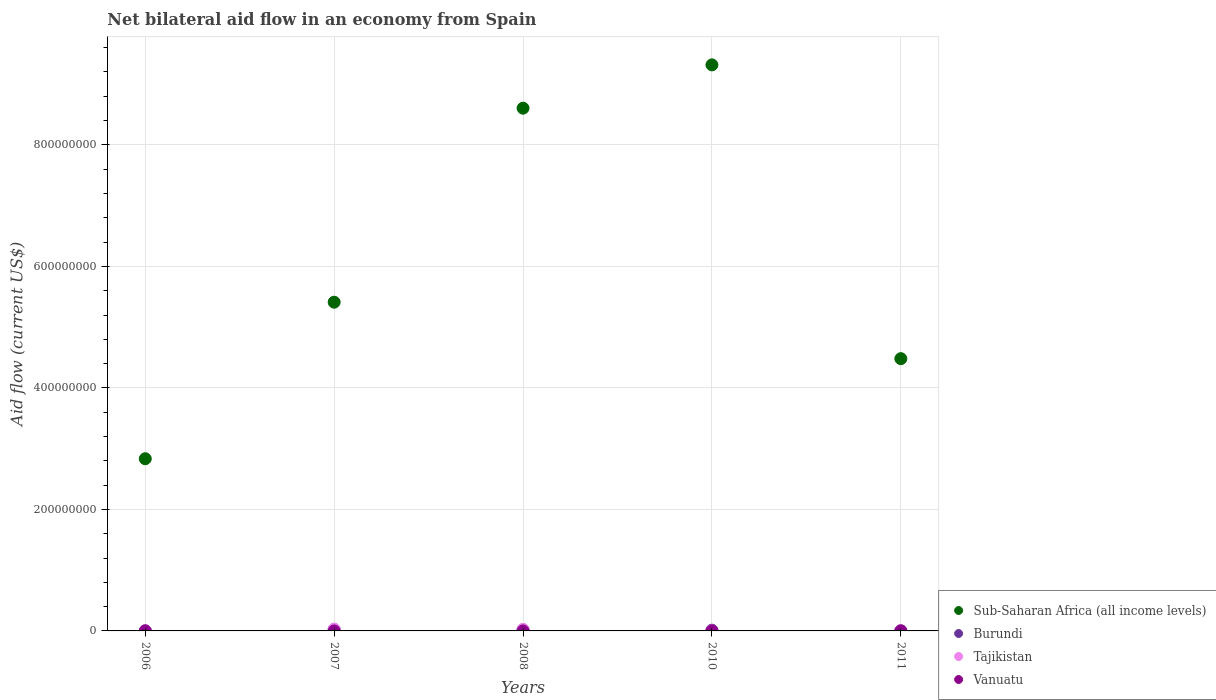How many different coloured dotlines are there?
Your answer should be very brief. 4. What is the net bilateral aid flow in Burundi in 2008?
Give a very brief answer. 1.88e+06. Across all years, what is the maximum net bilateral aid flow in Tajikistan?
Offer a very short reply. 3.04e+06. In which year was the net bilateral aid flow in Vanuatu maximum?
Offer a very short reply. 2011. In which year was the net bilateral aid flow in Vanuatu minimum?
Your response must be concise. 2006. What is the total net bilateral aid flow in Tajikistan in the graph?
Your answer should be compact. 5.67e+06. What is the difference between the net bilateral aid flow in Burundi in 2006 and the net bilateral aid flow in Vanuatu in 2010?
Your answer should be compact. 1.90e+05. What is the average net bilateral aid flow in Burundi per year?
Your response must be concise. 1.17e+06. In the year 2011, what is the difference between the net bilateral aid flow in Vanuatu and net bilateral aid flow in Tajikistan?
Provide a succinct answer. -3.00e+04. In how many years, is the net bilateral aid flow in Burundi greater than 320000000 US$?
Offer a very short reply. 0. What is the ratio of the net bilateral aid flow in Vanuatu in 2007 to that in 2010?
Your response must be concise. 0.33. Is the net bilateral aid flow in Tajikistan in 2007 less than that in 2008?
Make the answer very short. No. Is the difference between the net bilateral aid flow in Vanuatu in 2007 and 2010 greater than the difference between the net bilateral aid flow in Tajikistan in 2007 and 2010?
Offer a very short reply. No. What is the difference between the highest and the lowest net bilateral aid flow in Sub-Saharan Africa (all income levels)?
Keep it short and to the point. 6.48e+08. In how many years, is the net bilateral aid flow in Sub-Saharan Africa (all income levels) greater than the average net bilateral aid flow in Sub-Saharan Africa (all income levels) taken over all years?
Your response must be concise. 2. Is the sum of the net bilateral aid flow in Tajikistan in 2007 and 2011 greater than the maximum net bilateral aid flow in Sub-Saharan Africa (all income levels) across all years?
Keep it short and to the point. No. Is it the case that in every year, the sum of the net bilateral aid flow in Vanuatu and net bilateral aid flow in Tajikistan  is greater than the sum of net bilateral aid flow in Sub-Saharan Africa (all income levels) and net bilateral aid flow in Burundi?
Provide a succinct answer. No. Is it the case that in every year, the sum of the net bilateral aid flow in Vanuatu and net bilateral aid flow in Burundi  is greater than the net bilateral aid flow in Tajikistan?
Provide a succinct answer. No. How many dotlines are there?
Provide a succinct answer. 4. What is the difference between two consecutive major ticks on the Y-axis?
Offer a very short reply. 2.00e+08. Does the graph contain any zero values?
Keep it short and to the point. No. Does the graph contain grids?
Provide a short and direct response. Yes. How many legend labels are there?
Your answer should be very brief. 4. How are the legend labels stacked?
Ensure brevity in your answer.  Vertical. What is the title of the graph?
Your answer should be very brief. Net bilateral aid flow in an economy from Spain. Does "Isle of Man" appear as one of the legend labels in the graph?
Offer a very short reply. No. What is the label or title of the X-axis?
Your response must be concise. Years. What is the Aid flow (current US$) of Sub-Saharan Africa (all income levels) in 2006?
Your answer should be very brief. 2.83e+08. What is the Aid flow (current US$) in Vanuatu in 2006?
Your response must be concise. 10000. What is the Aid flow (current US$) of Sub-Saharan Africa (all income levels) in 2007?
Your answer should be compact. 5.41e+08. What is the Aid flow (current US$) of Burundi in 2007?
Offer a very short reply. 2.29e+06. What is the Aid flow (current US$) of Tajikistan in 2007?
Offer a very short reply. 3.04e+06. What is the Aid flow (current US$) of Vanuatu in 2007?
Your answer should be compact. 10000. What is the Aid flow (current US$) in Sub-Saharan Africa (all income levels) in 2008?
Provide a succinct answer. 8.60e+08. What is the Aid flow (current US$) of Burundi in 2008?
Offer a very short reply. 1.88e+06. What is the Aid flow (current US$) of Tajikistan in 2008?
Give a very brief answer. 2.49e+06. What is the Aid flow (current US$) in Sub-Saharan Africa (all income levels) in 2010?
Give a very brief answer. 9.32e+08. What is the Aid flow (current US$) in Burundi in 2010?
Your answer should be compact. 1.24e+06. What is the Aid flow (current US$) in Vanuatu in 2010?
Give a very brief answer. 3.00e+04. What is the Aid flow (current US$) of Sub-Saharan Africa (all income levels) in 2011?
Offer a terse response. 4.48e+08. What is the Aid flow (current US$) in Burundi in 2011?
Ensure brevity in your answer.  2.00e+05. What is the Aid flow (current US$) of Tajikistan in 2011?
Offer a terse response. 7.00e+04. What is the Aid flow (current US$) of Vanuatu in 2011?
Offer a terse response. 4.00e+04. Across all years, what is the maximum Aid flow (current US$) in Sub-Saharan Africa (all income levels)?
Your answer should be very brief. 9.32e+08. Across all years, what is the maximum Aid flow (current US$) in Burundi?
Your response must be concise. 2.29e+06. Across all years, what is the maximum Aid flow (current US$) in Tajikistan?
Give a very brief answer. 3.04e+06. Across all years, what is the maximum Aid flow (current US$) in Vanuatu?
Offer a very short reply. 4.00e+04. Across all years, what is the minimum Aid flow (current US$) of Sub-Saharan Africa (all income levels)?
Your answer should be compact. 2.83e+08. Across all years, what is the minimum Aid flow (current US$) in Tajikistan?
Your answer should be very brief. 2.00e+04. Across all years, what is the minimum Aid flow (current US$) of Vanuatu?
Keep it short and to the point. 10000. What is the total Aid flow (current US$) in Sub-Saharan Africa (all income levels) in the graph?
Your answer should be compact. 3.06e+09. What is the total Aid flow (current US$) in Burundi in the graph?
Keep it short and to the point. 5.83e+06. What is the total Aid flow (current US$) in Tajikistan in the graph?
Keep it short and to the point. 5.67e+06. What is the difference between the Aid flow (current US$) in Sub-Saharan Africa (all income levels) in 2006 and that in 2007?
Provide a short and direct response. -2.58e+08. What is the difference between the Aid flow (current US$) in Burundi in 2006 and that in 2007?
Provide a short and direct response. -2.07e+06. What is the difference between the Aid flow (current US$) of Tajikistan in 2006 and that in 2007?
Offer a terse response. -2.99e+06. What is the difference between the Aid flow (current US$) in Sub-Saharan Africa (all income levels) in 2006 and that in 2008?
Your answer should be compact. -5.77e+08. What is the difference between the Aid flow (current US$) of Burundi in 2006 and that in 2008?
Provide a succinct answer. -1.66e+06. What is the difference between the Aid flow (current US$) of Tajikistan in 2006 and that in 2008?
Offer a terse response. -2.44e+06. What is the difference between the Aid flow (current US$) in Vanuatu in 2006 and that in 2008?
Your answer should be very brief. -2.00e+04. What is the difference between the Aid flow (current US$) of Sub-Saharan Africa (all income levels) in 2006 and that in 2010?
Offer a very short reply. -6.48e+08. What is the difference between the Aid flow (current US$) in Burundi in 2006 and that in 2010?
Offer a very short reply. -1.02e+06. What is the difference between the Aid flow (current US$) of Vanuatu in 2006 and that in 2010?
Offer a terse response. -2.00e+04. What is the difference between the Aid flow (current US$) in Sub-Saharan Africa (all income levels) in 2006 and that in 2011?
Your answer should be compact. -1.65e+08. What is the difference between the Aid flow (current US$) of Burundi in 2006 and that in 2011?
Your answer should be very brief. 2.00e+04. What is the difference between the Aid flow (current US$) in Vanuatu in 2006 and that in 2011?
Give a very brief answer. -3.00e+04. What is the difference between the Aid flow (current US$) in Sub-Saharan Africa (all income levels) in 2007 and that in 2008?
Provide a short and direct response. -3.19e+08. What is the difference between the Aid flow (current US$) in Sub-Saharan Africa (all income levels) in 2007 and that in 2010?
Provide a short and direct response. -3.91e+08. What is the difference between the Aid flow (current US$) of Burundi in 2007 and that in 2010?
Keep it short and to the point. 1.05e+06. What is the difference between the Aid flow (current US$) of Tajikistan in 2007 and that in 2010?
Provide a succinct answer. 3.02e+06. What is the difference between the Aid flow (current US$) of Vanuatu in 2007 and that in 2010?
Ensure brevity in your answer.  -2.00e+04. What is the difference between the Aid flow (current US$) of Sub-Saharan Africa (all income levels) in 2007 and that in 2011?
Provide a short and direct response. 9.29e+07. What is the difference between the Aid flow (current US$) of Burundi in 2007 and that in 2011?
Your answer should be very brief. 2.09e+06. What is the difference between the Aid flow (current US$) of Tajikistan in 2007 and that in 2011?
Provide a succinct answer. 2.97e+06. What is the difference between the Aid flow (current US$) in Sub-Saharan Africa (all income levels) in 2008 and that in 2010?
Make the answer very short. -7.13e+07. What is the difference between the Aid flow (current US$) in Burundi in 2008 and that in 2010?
Your answer should be very brief. 6.40e+05. What is the difference between the Aid flow (current US$) in Tajikistan in 2008 and that in 2010?
Make the answer very short. 2.47e+06. What is the difference between the Aid flow (current US$) in Sub-Saharan Africa (all income levels) in 2008 and that in 2011?
Provide a short and direct response. 4.12e+08. What is the difference between the Aid flow (current US$) in Burundi in 2008 and that in 2011?
Make the answer very short. 1.68e+06. What is the difference between the Aid flow (current US$) in Tajikistan in 2008 and that in 2011?
Your answer should be compact. 2.42e+06. What is the difference between the Aid flow (current US$) in Vanuatu in 2008 and that in 2011?
Make the answer very short. -10000. What is the difference between the Aid flow (current US$) of Sub-Saharan Africa (all income levels) in 2010 and that in 2011?
Your answer should be very brief. 4.84e+08. What is the difference between the Aid flow (current US$) of Burundi in 2010 and that in 2011?
Your answer should be very brief. 1.04e+06. What is the difference between the Aid flow (current US$) in Tajikistan in 2010 and that in 2011?
Make the answer very short. -5.00e+04. What is the difference between the Aid flow (current US$) in Sub-Saharan Africa (all income levels) in 2006 and the Aid flow (current US$) in Burundi in 2007?
Keep it short and to the point. 2.81e+08. What is the difference between the Aid flow (current US$) in Sub-Saharan Africa (all income levels) in 2006 and the Aid flow (current US$) in Tajikistan in 2007?
Keep it short and to the point. 2.80e+08. What is the difference between the Aid flow (current US$) of Sub-Saharan Africa (all income levels) in 2006 and the Aid flow (current US$) of Vanuatu in 2007?
Your answer should be very brief. 2.83e+08. What is the difference between the Aid flow (current US$) of Burundi in 2006 and the Aid flow (current US$) of Tajikistan in 2007?
Provide a short and direct response. -2.82e+06. What is the difference between the Aid flow (current US$) of Tajikistan in 2006 and the Aid flow (current US$) of Vanuatu in 2007?
Provide a succinct answer. 4.00e+04. What is the difference between the Aid flow (current US$) of Sub-Saharan Africa (all income levels) in 2006 and the Aid flow (current US$) of Burundi in 2008?
Make the answer very short. 2.82e+08. What is the difference between the Aid flow (current US$) of Sub-Saharan Africa (all income levels) in 2006 and the Aid flow (current US$) of Tajikistan in 2008?
Keep it short and to the point. 2.81e+08. What is the difference between the Aid flow (current US$) in Sub-Saharan Africa (all income levels) in 2006 and the Aid flow (current US$) in Vanuatu in 2008?
Give a very brief answer. 2.83e+08. What is the difference between the Aid flow (current US$) of Burundi in 2006 and the Aid flow (current US$) of Tajikistan in 2008?
Provide a short and direct response. -2.27e+06. What is the difference between the Aid flow (current US$) in Sub-Saharan Africa (all income levels) in 2006 and the Aid flow (current US$) in Burundi in 2010?
Ensure brevity in your answer.  2.82e+08. What is the difference between the Aid flow (current US$) in Sub-Saharan Africa (all income levels) in 2006 and the Aid flow (current US$) in Tajikistan in 2010?
Provide a succinct answer. 2.83e+08. What is the difference between the Aid flow (current US$) of Sub-Saharan Africa (all income levels) in 2006 and the Aid flow (current US$) of Vanuatu in 2010?
Offer a terse response. 2.83e+08. What is the difference between the Aid flow (current US$) in Sub-Saharan Africa (all income levels) in 2006 and the Aid flow (current US$) in Burundi in 2011?
Your answer should be very brief. 2.83e+08. What is the difference between the Aid flow (current US$) of Sub-Saharan Africa (all income levels) in 2006 and the Aid flow (current US$) of Tajikistan in 2011?
Keep it short and to the point. 2.83e+08. What is the difference between the Aid flow (current US$) in Sub-Saharan Africa (all income levels) in 2006 and the Aid flow (current US$) in Vanuatu in 2011?
Offer a terse response. 2.83e+08. What is the difference between the Aid flow (current US$) of Burundi in 2006 and the Aid flow (current US$) of Vanuatu in 2011?
Provide a succinct answer. 1.80e+05. What is the difference between the Aid flow (current US$) in Tajikistan in 2006 and the Aid flow (current US$) in Vanuatu in 2011?
Your response must be concise. 10000. What is the difference between the Aid flow (current US$) in Sub-Saharan Africa (all income levels) in 2007 and the Aid flow (current US$) in Burundi in 2008?
Ensure brevity in your answer.  5.39e+08. What is the difference between the Aid flow (current US$) of Sub-Saharan Africa (all income levels) in 2007 and the Aid flow (current US$) of Tajikistan in 2008?
Keep it short and to the point. 5.39e+08. What is the difference between the Aid flow (current US$) of Sub-Saharan Africa (all income levels) in 2007 and the Aid flow (current US$) of Vanuatu in 2008?
Your response must be concise. 5.41e+08. What is the difference between the Aid flow (current US$) of Burundi in 2007 and the Aid flow (current US$) of Tajikistan in 2008?
Keep it short and to the point. -2.00e+05. What is the difference between the Aid flow (current US$) in Burundi in 2007 and the Aid flow (current US$) in Vanuatu in 2008?
Make the answer very short. 2.26e+06. What is the difference between the Aid flow (current US$) in Tajikistan in 2007 and the Aid flow (current US$) in Vanuatu in 2008?
Your response must be concise. 3.01e+06. What is the difference between the Aid flow (current US$) in Sub-Saharan Africa (all income levels) in 2007 and the Aid flow (current US$) in Burundi in 2010?
Provide a short and direct response. 5.40e+08. What is the difference between the Aid flow (current US$) in Sub-Saharan Africa (all income levels) in 2007 and the Aid flow (current US$) in Tajikistan in 2010?
Offer a very short reply. 5.41e+08. What is the difference between the Aid flow (current US$) in Sub-Saharan Africa (all income levels) in 2007 and the Aid flow (current US$) in Vanuatu in 2010?
Offer a terse response. 5.41e+08. What is the difference between the Aid flow (current US$) of Burundi in 2007 and the Aid flow (current US$) of Tajikistan in 2010?
Give a very brief answer. 2.27e+06. What is the difference between the Aid flow (current US$) in Burundi in 2007 and the Aid flow (current US$) in Vanuatu in 2010?
Your response must be concise. 2.26e+06. What is the difference between the Aid flow (current US$) of Tajikistan in 2007 and the Aid flow (current US$) of Vanuatu in 2010?
Provide a succinct answer. 3.01e+06. What is the difference between the Aid flow (current US$) in Sub-Saharan Africa (all income levels) in 2007 and the Aid flow (current US$) in Burundi in 2011?
Ensure brevity in your answer.  5.41e+08. What is the difference between the Aid flow (current US$) in Sub-Saharan Africa (all income levels) in 2007 and the Aid flow (current US$) in Tajikistan in 2011?
Your answer should be very brief. 5.41e+08. What is the difference between the Aid flow (current US$) in Sub-Saharan Africa (all income levels) in 2007 and the Aid flow (current US$) in Vanuatu in 2011?
Offer a very short reply. 5.41e+08. What is the difference between the Aid flow (current US$) in Burundi in 2007 and the Aid flow (current US$) in Tajikistan in 2011?
Provide a short and direct response. 2.22e+06. What is the difference between the Aid flow (current US$) in Burundi in 2007 and the Aid flow (current US$) in Vanuatu in 2011?
Your answer should be very brief. 2.25e+06. What is the difference between the Aid flow (current US$) of Sub-Saharan Africa (all income levels) in 2008 and the Aid flow (current US$) of Burundi in 2010?
Give a very brief answer. 8.59e+08. What is the difference between the Aid flow (current US$) of Sub-Saharan Africa (all income levels) in 2008 and the Aid flow (current US$) of Tajikistan in 2010?
Your response must be concise. 8.60e+08. What is the difference between the Aid flow (current US$) of Sub-Saharan Africa (all income levels) in 2008 and the Aid flow (current US$) of Vanuatu in 2010?
Offer a very short reply. 8.60e+08. What is the difference between the Aid flow (current US$) of Burundi in 2008 and the Aid flow (current US$) of Tajikistan in 2010?
Ensure brevity in your answer.  1.86e+06. What is the difference between the Aid flow (current US$) in Burundi in 2008 and the Aid flow (current US$) in Vanuatu in 2010?
Your answer should be compact. 1.85e+06. What is the difference between the Aid flow (current US$) of Tajikistan in 2008 and the Aid flow (current US$) of Vanuatu in 2010?
Give a very brief answer. 2.46e+06. What is the difference between the Aid flow (current US$) in Sub-Saharan Africa (all income levels) in 2008 and the Aid flow (current US$) in Burundi in 2011?
Offer a terse response. 8.60e+08. What is the difference between the Aid flow (current US$) in Sub-Saharan Africa (all income levels) in 2008 and the Aid flow (current US$) in Tajikistan in 2011?
Provide a succinct answer. 8.60e+08. What is the difference between the Aid flow (current US$) in Sub-Saharan Africa (all income levels) in 2008 and the Aid flow (current US$) in Vanuatu in 2011?
Your answer should be compact. 8.60e+08. What is the difference between the Aid flow (current US$) in Burundi in 2008 and the Aid flow (current US$) in Tajikistan in 2011?
Make the answer very short. 1.81e+06. What is the difference between the Aid flow (current US$) in Burundi in 2008 and the Aid flow (current US$) in Vanuatu in 2011?
Provide a succinct answer. 1.84e+06. What is the difference between the Aid flow (current US$) in Tajikistan in 2008 and the Aid flow (current US$) in Vanuatu in 2011?
Keep it short and to the point. 2.45e+06. What is the difference between the Aid flow (current US$) of Sub-Saharan Africa (all income levels) in 2010 and the Aid flow (current US$) of Burundi in 2011?
Give a very brief answer. 9.32e+08. What is the difference between the Aid flow (current US$) of Sub-Saharan Africa (all income levels) in 2010 and the Aid flow (current US$) of Tajikistan in 2011?
Your answer should be very brief. 9.32e+08. What is the difference between the Aid flow (current US$) in Sub-Saharan Africa (all income levels) in 2010 and the Aid flow (current US$) in Vanuatu in 2011?
Ensure brevity in your answer.  9.32e+08. What is the difference between the Aid flow (current US$) in Burundi in 2010 and the Aid flow (current US$) in Tajikistan in 2011?
Your answer should be compact. 1.17e+06. What is the difference between the Aid flow (current US$) of Burundi in 2010 and the Aid flow (current US$) of Vanuatu in 2011?
Offer a terse response. 1.20e+06. What is the average Aid flow (current US$) in Sub-Saharan Africa (all income levels) per year?
Give a very brief answer. 6.13e+08. What is the average Aid flow (current US$) in Burundi per year?
Offer a terse response. 1.17e+06. What is the average Aid flow (current US$) in Tajikistan per year?
Give a very brief answer. 1.13e+06. What is the average Aid flow (current US$) in Vanuatu per year?
Offer a very short reply. 2.40e+04. In the year 2006, what is the difference between the Aid flow (current US$) of Sub-Saharan Africa (all income levels) and Aid flow (current US$) of Burundi?
Make the answer very short. 2.83e+08. In the year 2006, what is the difference between the Aid flow (current US$) in Sub-Saharan Africa (all income levels) and Aid flow (current US$) in Tajikistan?
Your answer should be compact. 2.83e+08. In the year 2006, what is the difference between the Aid flow (current US$) in Sub-Saharan Africa (all income levels) and Aid flow (current US$) in Vanuatu?
Offer a terse response. 2.83e+08. In the year 2006, what is the difference between the Aid flow (current US$) of Burundi and Aid flow (current US$) of Vanuatu?
Give a very brief answer. 2.10e+05. In the year 2006, what is the difference between the Aid flow (current US$) of Tajikistan and Aid flow (current US$) of Vanuatu?
Provide a succinct answer. 4.00e+04. In the year 2007, what is the difference between the Aid flow (current US$) in Sub-Saharan Africa (all income levels) and Aid flow (current US$) in Burundi?
Ensure brevity in your answer.  5.39e+08. In the year 2007, what is the difference between the Aid flow (current US$) in Sub-Saharan Africa (all income levels) and Aid flow (current US$) in Tajikistan?
Your answer should be very brief. 5.38e+08. In the year 2007, what is the difference between the Aid flow (current US$) in Sub-Saharan Africa (all income levels) and Aid flow (current US$) in Vanuatu?
Your answer should be compact. 5.41e+08. In the year 2007, what is the difference between the Aid flow (current US$) in Burundi and Aid flow (current US$) in Tajikistan?
Your response must be concise. -7.50e+05. In the year 2007, what is the difference between the Aid flow (current US$) in Burundi and Aid flow (current US$) in Vanuatu?
Your answer should be very brief. 2.28e+06. In the year 2007, what is the difference between the Aid flow (current US$) in Tajikistan and Aid flow (current US$) in Vanuatu?
Offer a terse response. 3.03e+06. In the year 2008, what is the difference between the Aid flow (current US$) of Sub-Saharan Africa (all income levels) and Aid flow (current US$) of Burundi?
Your answer should be very brief. 8.59e+08. In the year 2008, what is the difference between the Aid flow (current US$) of Sub-Saharan Africa (all income levels) and Aid flow (current US$) of Tajikistan?
Offer a terse response. 8.58e+08. In the year 2008, what is the difference between the Aid flow (current US$) of Sub-Saharan Africa (all income levels) and Aid flow (current US$) of Vanuatu?
Make the answer very short. 8.60e+08. In the year 2008, what is the difference between the Aid flow (current US$) of Burundi and Aid flow (current US$) of Tajikistan?
Offer a terse response. -6.10e+05. In the year 2008, what is the difference between the Aid flow (current US$) of Burundi and Aid flow (current US$) of Vanuatu?
Give a very brief answer. 1.85e+06. In the year 2008, what is the difference between the Aid flow (current US$) of Tajikistan and Aid flow (current US$) of Vanuatu?
Your answer should be compact. 2.46e+06. In the year 2010, what is the difference between the Aid flow (current US$) in Sub-Saharan Africa (all income levels) and Aid flow (current US$) in Burundi?
Provide a short and direct response. 9.30e+08. In the year 2010, what is the difference between the Aid flow (current US$) of Sub-Saharan Africa (all income levels) and Aid flow (current US$) of Tajikistan?
Provide a short and direct response. 9.32e+08. In the year 2010, what is the difference between the Aid flow (current US$) in Sub-Saharan Africa (all income levels) and Aid flow (current US$) in Vanuatu?
Keep it short and to the point. 9.32e+08. In the year 2010, what is the difference between the Aid flow (current US$) in Burundi and Aid flow (current US$) in Tajikistan?
Ensure brevity in your answer.  1.22e+06. In the year 2010, what is the difference between the Aid flow (current US$) of Burundi and Aid flow (current US$) of Vanuatu?
Your response must be concise. 1.21e+06. In the year 2010, what is the difference between the Aid flow (current US$) of Tajikistan and Aid flow (current US$) of Vanuatu?
Provide a short and direct response. -10000. In the year 2011, what is the difference between the Aid flow (current US$) in Sub-Saharan Africa (all income levels) and Aid flow (current US$) in Burundi?
Keep it short and to the point. 4.48e+08. In the year 2011, what is the difference between the Aid flow (current US$) in Sub-Saharan Africa (all income levels) and Aid flow (current US$) in Tajikistan?
Offer a terse response. 4.48e+08. In the year 2011, what is the difference between the Aid flow (current US$) in Sub-Saharan Africa (all income levels) and Aid flow (current US$) in Vanuatu?
Offer a terse response. 4.48e+08. In the year 2011, what is the difference between the Aid flow (current US$) of Burundi and Aid flow (current US$) of Tajikistan?
Provide a succinct answer. 1.30e+05. In the year 2011, what is the difference between the Aid flow (current US$) of Burundi and Aid flow (current US$) of Vanuatu?
Offer a terse response. 1.60e+05. In the year 2011, what is the difference between the Aid flow (current US$) in Tajikistan and Aid flow (current US$) in Vanuatu?
Offer a terse response. 3.00e+04. What is the ratio of the Aid flow (current US$) in Sub-Saharan Africa (all income levels) in 2006 to that in 2007?
Offer a terse response. 0.52. What is the ratio of the Aid flow (current US$) of Burundi in 2006 to that in 2007?
Your response must be concise. 0.1. What is the ratio of the Aid flow (current US$) of Tajikistan in 2006 to that in 2007?
Offer a very short reply. 0.02. What is the ratio of the Aid flow (current US$) of Sub-Saharan Africa (all income levels) in 2006 to that in 2008?
Ensure brevity in your answer.  0.33. What is the ratio of the Aid flow (current US$) of Burundi in 2006 to that in 2008?
Offer a terse response. 0.12. What is the ratio of the Aid flow (current US$) in Tajikistan in 2006 to that in 2008?
Offer a very short reply. 0.02. What is the ratio of the Aid flow (current US$) in Vanuatu in 2006 to that in 2008?
Provide a short and direct response. 0.33. What is the ratio of the Aid flow (current US$) of Sub-Saharan Africa (all income levels) in 2006 to that in 2010?
Give a very brief answer. 0.3. What is the ratio of the Aid flow (current US$) in Burundi in 2006 to that in 2010?
Give a very brief answer. 0.18. What is the ratio of the Aid flow (current US$) in Tajikistan in 2006 to that in 2010?
Offer a very short reply. 2.5. What is the ratio of the Aid flow (current US$) in Vanuatu in 2006 to that in 2010?
Offer a terse response. 0.33. What is the ratio of the Aid flow (current US$) of Sub-Saharan Africa (all income levels) in 2006 to that in 2011?
Keep it short and to the point. 0.63. What is the ratio of the Aid flow (current US$) in Burundi in 2006 to that in 2011?
Provide a short and direct response. 1.1. What is the ratio of the Aid flow (current US$) in Tajikistan in 2006 to that in 2011?
Offer a very short reply. 0.71. What is the ratio of the Aid flow (current US$) in Vanuatu in 2006 to that in 2011?
Ensure brevity in your answer.  0.25. What is the ratio of the Aid flow (current US$) of Sub-Saharan Africa (all income levels) in 2007 to that in 2008?
Make the answer very short. 0.63. What is the ratio of the Aid flow (current US$) of Burundi in 2007 to that in 2008?
Offer a terse response. 1.22. What is the ratio of the Aid flow (current US$) of Tajikistan in 2007 to that in 2008?
Keep it short and to the point. 1.22. What is the ratio of the Aid flow (current US$) of Vanuatu in 2007 to that in 2008?
Offer a very short reply. 0.33. What is the ratio of the Aid flow (current US$) in Sub-Saharan Africa (all income levels) in 2007 to that in 2010?
Provide a short and direct response. 0.58. What is the ratio of the Aid flow (current US$) in Burundi in 2007 to that in 2010?
Offer a very short reply. 1.85. What is the ratio of the Aid flow (current US$) of Tajikistan in 2007 to that in 2010?
Ensure brevity in your answer.  152. What is the ratio of the Aid flow (current US$) in Sub-Saharan Africa (all income levels) in 2007 to that in 2011?
Provide a succinct answer. 1.21. What is the ratio of the Aid flow (current US$) in Burundi in 2007 to that in 2011?
Ensure brevity in your answer.  11.45. What is the ratio of the Aid flow (current US$) in Tajikistan in 2007 to that in 2011?
Your answer should be compact. 43.43. What is the ratio of the Aid flow (current US$) of Sub-Saharan Africa (all income levels) in 2008 to that in 2010?
Your answer should be very brief. 0.92. What is the ratio of the Aid flow (current US$) of Burundi in 2008 to that in 2010?
Provide a succinct answer. 1.52. What is the ratio of the Aid flow (current US$) of Tajikistan in 2008 to that in 2010?
Make the answer very short. 124.5. What is the ratio of the Aid flow (current US$) in Sub-Saharan Africa (all income levels) in 2008 to that in 2011?
Make the answer very short. 1.92. What is the ratio of the Aid flow (current US$) in Tajikistan in 2008 to that in 2011?
Keep it short and to the point. 35.57. What is the ratio of the Aid flow (current US$) of Vanuatu in 2008 to that in 2011?
Give a very brief answer. 0.75. What is the ratio of the Aid flow (current US$) in Sub-Saharan Africa (all income levels) in 2010 to that in 2011?
Offer a terse response. 2.08. What is the ratio of the Aid flow (current US$) in Burundi in 2010 to that in 2011?
Offer a terse response. 6.2. What is the ratio of the Aid flow (current US$) in Tajikistan in 2010 to that in 2011?
Ensure brevity in your answer.  0.29. What is the difference between the highest and the second highest Aid flow (current US$) in Sub-Saharan Africa (all income levels)?
Ensure brevity in your answer.  7.13e+07. What is the difference between the highest and the second highest Aid flow (current US$) of Burundi?
Offer a very short reply. 4.10e+05. What is the difference between the highest and the second highest Aid flow (current US$) of Vanuatu?
Give a very brief answer. 10000. What is the difference between the highest and the lowest Aid flow (current US$) in Sub-Saharan Africa (all income levels)?
Offer a very short reply. 6.48e+08. What is the difference between the highest and the lowest Aid flow (current US$) of Burundi?
Keep it short and to the point. 2.09e+06. What is the difference between the highest and the lowest Aid flow (current US$) of Tajikistan?
Your response must be concise. 3.02e+06. What is the difference between the highest and the lowest Aid flow (current US$) of Vanuatu?
Your response must be concise. 3.00e+04. 